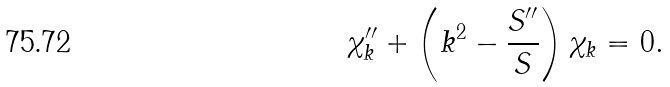Convert formula to latex. <formula><loc_0><loc_0><loc_500><loc_500>\chi _ { k } ^ { \prime \prime } + \left ( k ^ { 2 } - \frac { S ^ { \prime \prime } } S \right ) \chi _ { k } = 0 .</formula> 